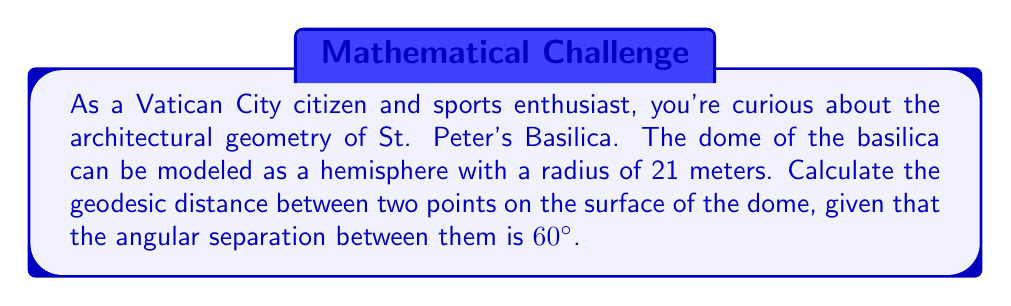Show me your answer to this math problem. Let's approach this step-by-step:

1) The dome of St. Peter's Basilica is modeled as a hemisphere with radius $r = 21$ meters.

2) The geodesic distance between two points on a sphere (or hemisphere) is given by the arc length of the great circle passing through those points.

3) The formula for the geodesic distance $d$ on a sphere is:

   $$d = r\theta$$

   where $r$ is the radius of the sphere and $\theta$ is the angular separation in radians.

4) We're given the angular separation in degrees (60°). We need to convert this to radians:

   $$\theta = 60° \times \frac{\pi}{180°} = \frac{\pi}{3} \text{ radians}$$

5) Now we can substitute our values into the formula:

   $$d = 21 \times \frac{\pi}{3}$$

6) Simplifying:

   $$d = 7\pi \text{ meters}$$

7) If we want to express this as a decimal, we can calculate:

   $$d \approx 21.991 \text{ meters}$$

[asy]
import geometry;

size(200);
real r = 5;
path c = circle((0,0),r);
draw(c);
draw((0,0)--(r,0),dashed);
draw((0,0)--(r*cos(pi/3),r*sin(pi/3)),dashed);
draw(arc((0,0),r,0,60),red+1);
label("60°",(r/2,r/4),NE);
label("r",(r/2,0),S);
label("d",(r*cos(pi/6),r*sin(pi/6)),NW);
[/asy]
Answer: $7\pi$ meters (approximately 21.991 meters) 